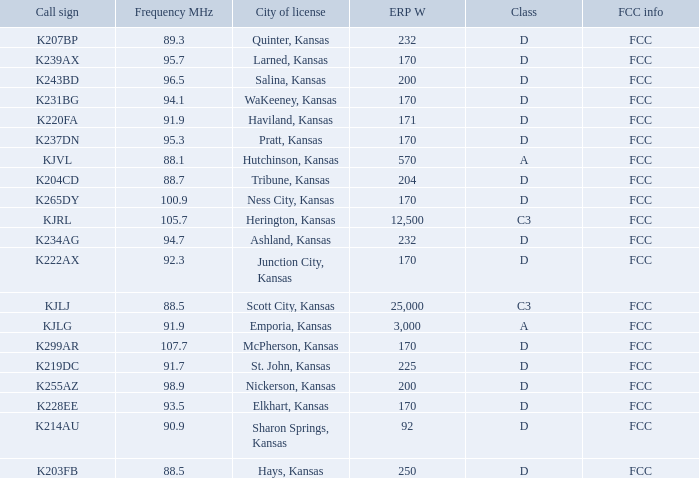Call sign of k231bg has what sum of erp w? 170.0. Help me parse the entirety of this table. {'header': ['Call sign', 'Frequency MHz', 'City of license', 'ERP W', 'Class', 'FCC info'], 'rows': [['K207BP', '89.3', 'Quinter, Kansas', '232', 'D', 'FCC'], ['K239AX', '95.7', 'Larned, Kansas', '170', 'D', 'FCC'], ['K243BD', '96.5', 'Salina, Kansas', '200', 'D', 'FCC'], ['K231BG', '94.1', 'WaKeeney, Kansas', '170', 'D', 'FCC'], ['K220FA', '91.9', 'Haviland, Kansas', '171', 'D', 'FCC'], ['K237DN', '95.3', 'Pratt, Kansas', '170', 'D', 'FCC'], ['KJVL', '88.1', 'Hutchinson, Kansas', '570', 'A', 'FCC'], ['K204CD', '88.7', 'Tribune, Kansas', '204', 'D', 'FCC'], ['K265DY', '100.9', 'Ness City, Kansas', '170', 'D', 'FCC'], ['KJRL', '105.7', 'Herington, Kansas', '12,500', 'C3', 'FCC'], ['K234AG', '94.7', 'Ashland, Kansas', '232', 'D', 'FCC'], ['K222AX', '92.3', 'Junction City, Kansas', '170', 'D', 'FCC'], ['KJLJ', '88.5', 'Scott City, Kansas', '25,000', 'C3', 'FCC'], ['KJLG', '91.9', 'Emporia, Kansas', '3,000', 'A', 'FCC'], ['K299AR', '107.7', 'McPherson, Kansas', '170', 'D', 'FCC'], ['K219DC', '91.7', 'St. John, Kansas', '225', 'D', 'FCC'], ['K255AZ', '98.9', 'Nickerson, Kansas', '200', 'D', 'FCC'], ['K228EE', '93.5', 'Elkhart, Kansas', '170', 'D', 'FCC'], ['K214AU', '90.9', 'Sharon Springs, Kansas', '92', 'D', 'FCC'], ['K203FB', '88.5', 'Hays, Kansas', '250', 'D', 'FCC']]} 